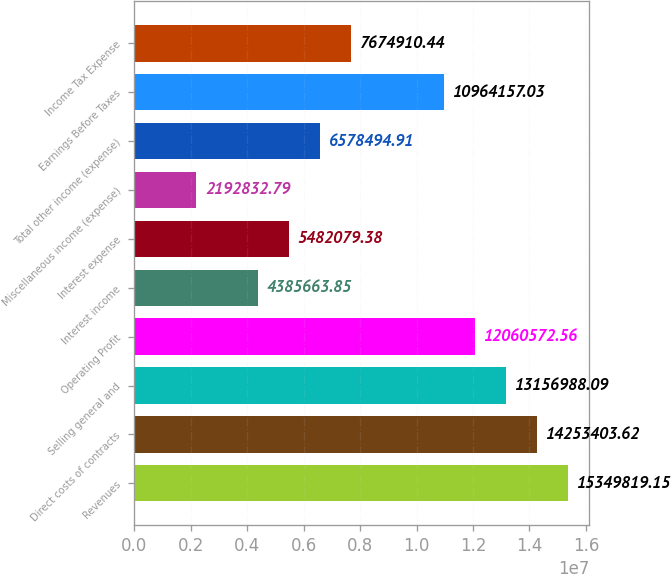Convert chart to OTSL. <chart><loc_0><loc_0><loc_500><loc_500><bar_chart><fcel>Revenues<fcel>Direct costs of contracts<fcel>Selling general and<fcel>Operating Profit<fcel>Interest income<fcel>Interest expense<fcel>Miscellaneous income (expense)<fcel>Total other income (expense)<fcel>Earnings Before Taxes<fcel>Income Tax Expense<nl><fcel>1.53498e+07<fcel>1.42534e+07<fcel>1.3157e+07<fcel>1.20606e+07<fcel>4.38566e+06<fcel>5.48208e+06<fcel>2.19283e+06<fcel>6.57849e+06<fcel>1.09642e+07<fcel>7.67491e+06<nl></chart> 